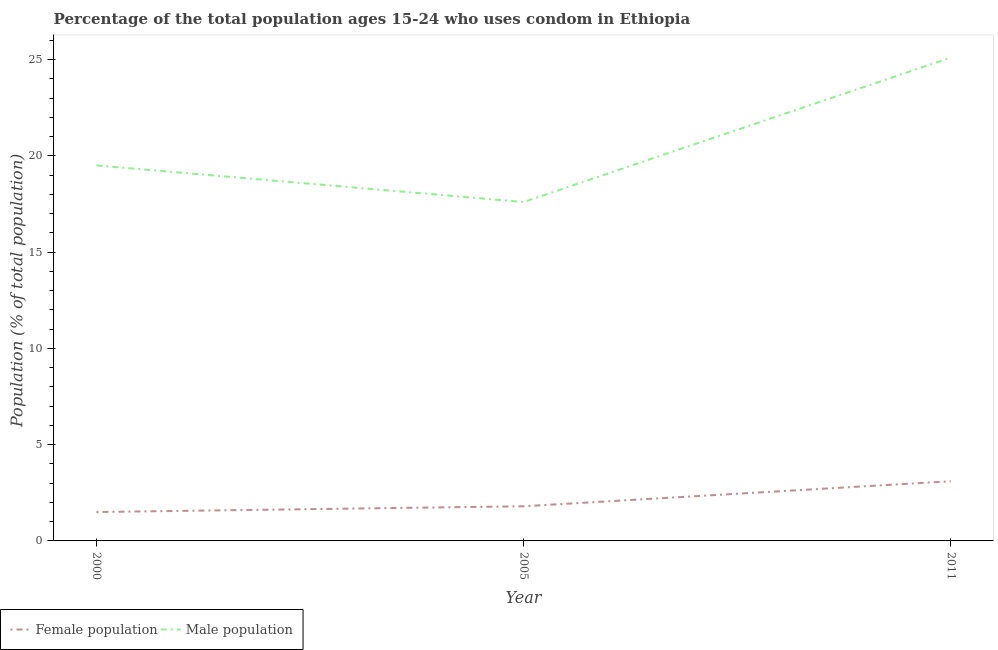Does the line corresponding to female population intersect with the line corresponding to male population?
Make the answer very short. No. What is the female population in 2011?
Make the answer very short. 3.1. Across all years, what is the maximum female population?
Ensure brevity in your answer.  3.1. Across all years, what is the minimum male population?
Your response must be concise. 17.6. In which year was the female population maximum?
Provide a short and direct response. 2011. In which year was the male population minimum?
Give a very brief answer. 2005. What is the total female population in the graph?
Keep it short and to the point. 6.4. What is the difference between the male population in 2005 and that in 2011?
Give a very brief answer. -7.5. What is the difference between the female population in 2011 and the male population in 2000?
Provide a short and direct response. -16.4. What is the average female population per year?
Ensure brevity in your answer.  2.13. In the year 2011, what is the difference between the male population and female population?
Offer a terse response. 22. In how many years, is the male population greater than 19 %?
Provide a succinct answer. 2. What is the ratio of the female population in 2000 to that in 2011?
Provide a short and direct response. 0.48. Is the male population in 2005 less than that in 2011?
Your response must be concise. Yes. Is the difference between the female population in 2000 and 2005 greater than the difference between the male population in 2000 and 2005?
Make the answer very short. No. What is the difference between the highest and the second highest male population?
Provide a short and direct response. 5.6. What is the difference between the highest and the lowest female population?
Make the answer very short. 1.6. Does the male population monotonically increase over the years?
Keep it short and to the point. No. Is the male population strictly greater than the female population over the years?
Keep it short and to the point. Yes. What is the difference between two consecutive major ticks on the Y-axis?
Provide a succinct answer. 5. Does the graph contain grids?
Ensure brevity in your answer.  No. Where does the legend appear in the graph?
Offer a terse response. Bottom left. How many legend labels are there?
Make the answer very short. 2. What is the title of the graph?
Your response must be concise. Percentage of the total population ages 15-24 who uses condom in Ethiopia. What is the label or title of the X-axis?
Provide a succinct answer. Year. What is the label or title of the Y-axis?
Your response must be concise. Population (% of total population) . What is the Population (% of total population)  of Male population in 2000?
Your answer should be very brief. 19.5. What is the Population (% of total population)  of Male population in 2005?
Keep it short and to the point. 17.6. What is the Population (% of total population)  in Male population in 2011?
Keep it short and to the point. 25.1. Across all years, what is the maximum Population (% of total population)  in Male population?
Your response must be concise. 25.1. What is the total Population (% of total population)  of Male population in the graph?
Offer a very short reply. 62.2. What is the difference between the Population (% of total population)  of Male population in 2000 and that in 2005?
Your answer should be compact. 1.9. What is the difference between the Population (% of total population)  in Female population in 2000 and that in 2011?
Your answer should be very brief. -1.6. What is the difference between the Population (% of total population)  of Male population in 2005 and that in 2011?
Your answer should be very brief. -7.5. What is the difference between the Population (% of total population)  in Female population in 2000 and the Population (% of total population)  in Male population in 2005?
Your response must be concise. -16.1. What is the difference between the Population (% of total population)  in Female population in 2000 and the Population (% of total population)  in Male population in 2011?
Offer a very short reply. -23.6. What is the difference between the Population (% of total population)  of Female population in 2005 and the Population (% of total population)  of Male population in 2011?
Give a very brief answer. -23.3. What is the average Population (% of total population)  of Female population per year?
Provide a succinct answer. 2.13. What is the average Population (% of total population)  of Male population per year?
Make the answer very short. 20.73. In the year 2000, what is the difference between the Population (% of total population)  in Female population and Population (% of total population)  in Male population?
Offer a terse response. -18. In the year 2005, what is the difference between the Population (% of total population)  of Female population and Population (% of total population)  of Male population?
Give a very brief answer. -15.8. In the year 2011, what is the difference between the Population (% of total population)  in Female population and Population (% of total population)  in Male population?
Your answer should be very brief. -22. What is the ratio of the Population (% of total population)  of Female population in 2000 to that in 2005?
Provide a short and direct response. 0.83. What is the ratio of the Population (% of total population)  of Male population in 2000 to that in 2005?
Your response must be concise. 1.11. What is the ratio of the Population (% of total population)  in Female population in 2000 to that in 2011?
Your response must be concise. 0.48. What is the ratio of the Population (% of total population)  in Male population in 2000 to that in 2011?
Your answer should be very brief. 0.78. What is the ratio of the Population (% of total population)  in Female population in 2005 to that in 2011?
Ensure brevity in your answer.  0.58. What is the ratio of the Population (% of total population)  of Male population in 2005 to that in 2011?
Make the answer very short. 0.7. What is the difference between the highest and the second highest Population (% of total population)  in Male population?
Keep it short and to the point. 5.6. What is the difference between the highest and the lowest Population (% of total population)  in Female population?
Make the answer very short. 1.6. 